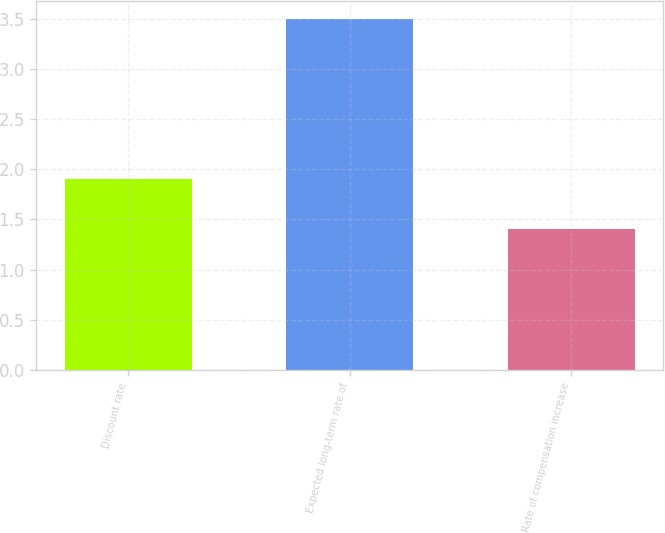Convert chart to OTSL. <chart><loc_0><loc_0><loc_500><loc_500><bar_chart><fcel>Discount rate<fcel>Expected long-term rate of<fcel>Rate of compensation increase<nl><fcel>1.9<fcel>3.5<fcel>1.4<nl></chart> 